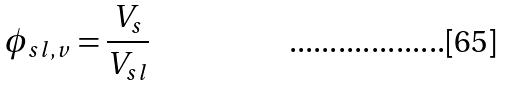Convert formula to latex. <formula><loc_0><loc_0><loc_500><loc_500>\phi _ { s l , v } = \frac { V _ { s } } { V _ { s l } }</formula> 